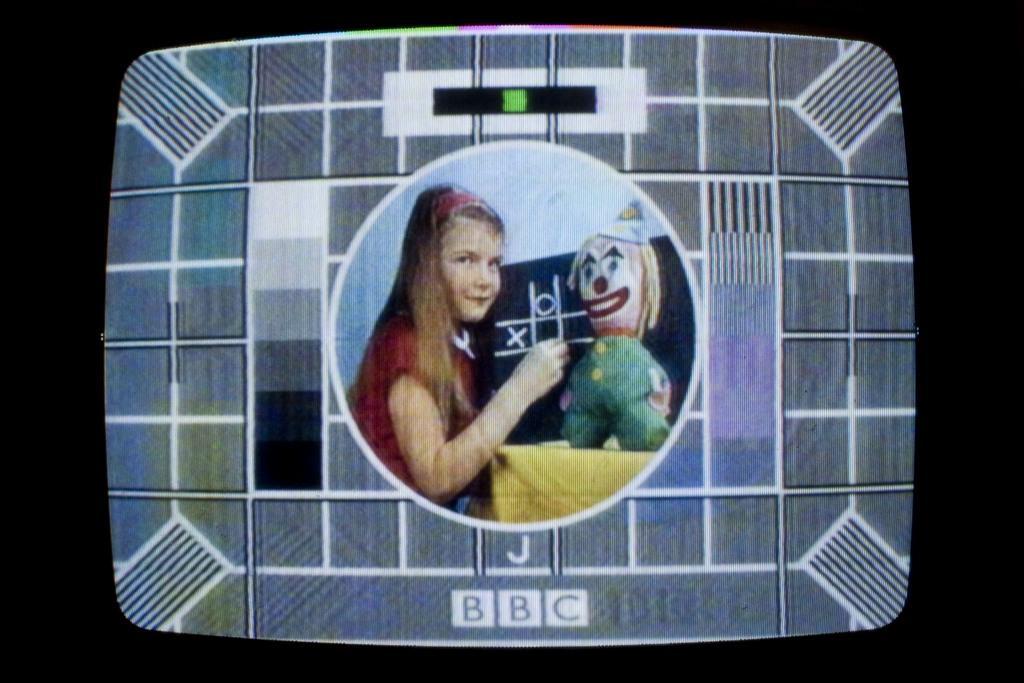In one or two sentences, can you explain what this image depicts? In this image we can see the picture in a television containing a child, doll and a board. 